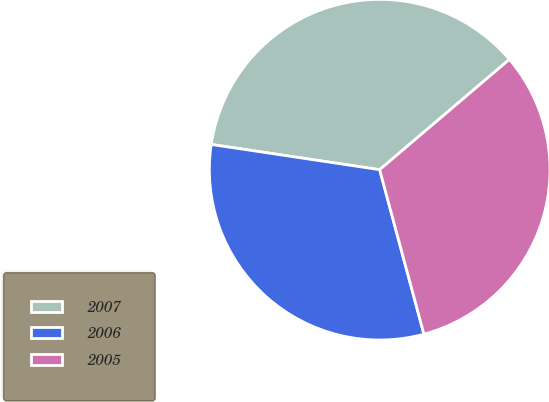<chart> <loc_0><loc_0><loc_500><loc_500><pie_chart><fcel>2007<fcel>2006<fcel>2005<nl><fcel>36.42%<fcel>31.55%<fcel>32.03%<nl></chart> 